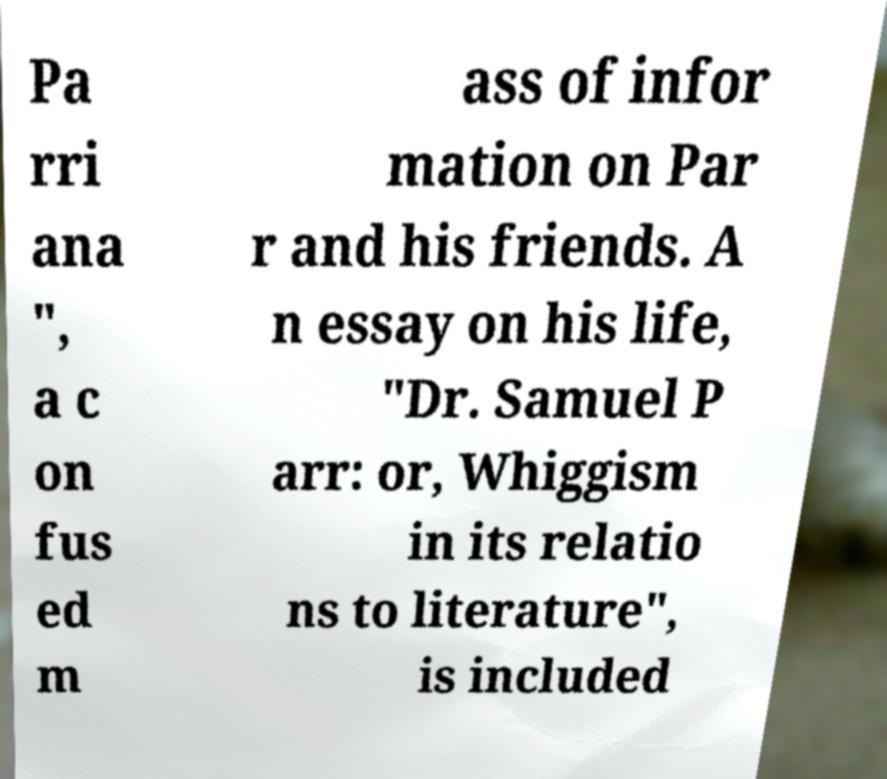Could you assist in decoding the text presented in this image and type it out clearly? Pa rri ana ", a c on fus ed m ass of infor mation on Par r and his friends. A n essay on his life, "Dr. Samuel P arr: or, Whiggism in its relatio ns to literature", is included 